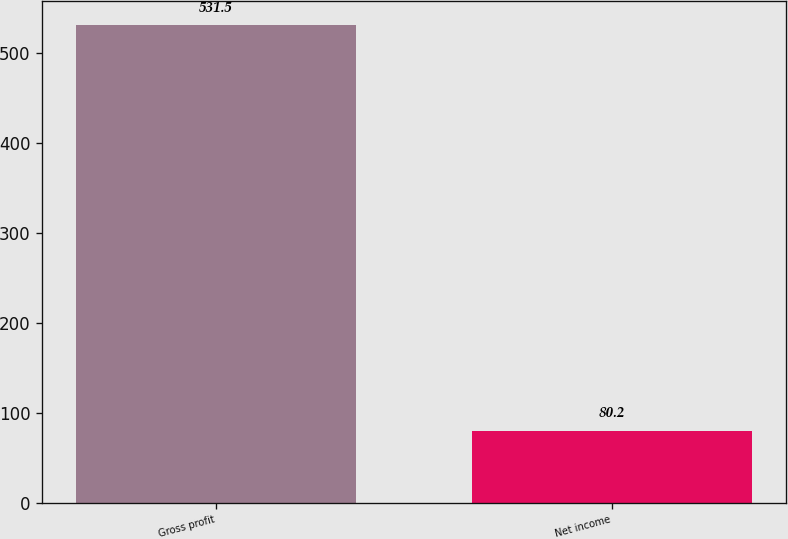Convert chart. <chart><loc_0><loc_0><loc_500><loc_500><bar_chart><fcel>Gross profit<fcel>Net income<nl><fcel>531.5<fcel>80.2<nl></chart> 